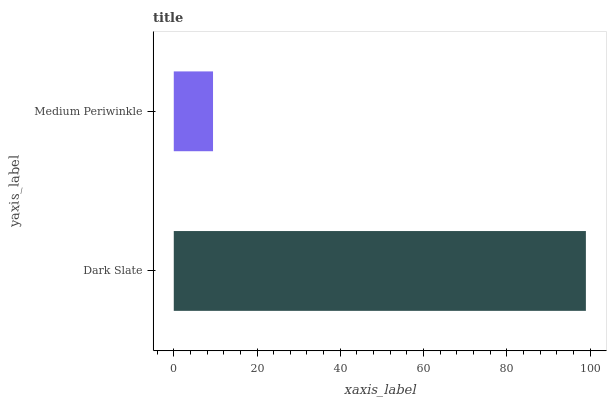Is Medium Periwinkle the minimum?
Answer yes or no. Yes. Is Dark Slate the maximum?
Answer yes or no. Yes. Is Medium Periwinkle the maximum?
Answer yes or no. No. Is Dark Slate greater than Medium Periwinkle?
Answer yes or no. Yes. Is Medium Periwinkle less than Dark Slate?
Answer yes or no. Yes. Is Medium Periwinkle greater than Dark Slate?
Answer yes or no. No. Is Dark Slate less than Medium Periwinkle?
Answer yes or no. No. Is Dark Slate the high median?
Answer yes or no. Yes. Is Medium Periwinkle the low median?
Answer yes or no. Yes. Is Medium Periwinkle the high median?
Answer yes or no. No. Is Dark Slate the low median?
Answer yes or no. No. 